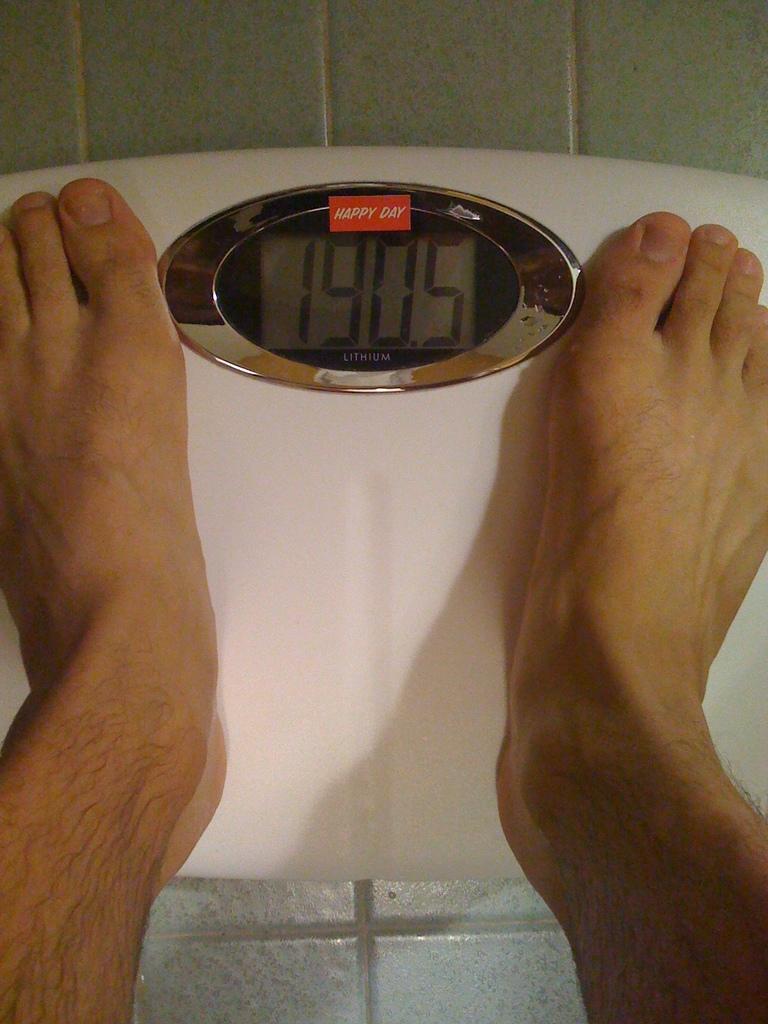What does this man weigh?
Provide a succinct answer. 190.5. What is the brand name?
Your answer should be compact. Happy day. 